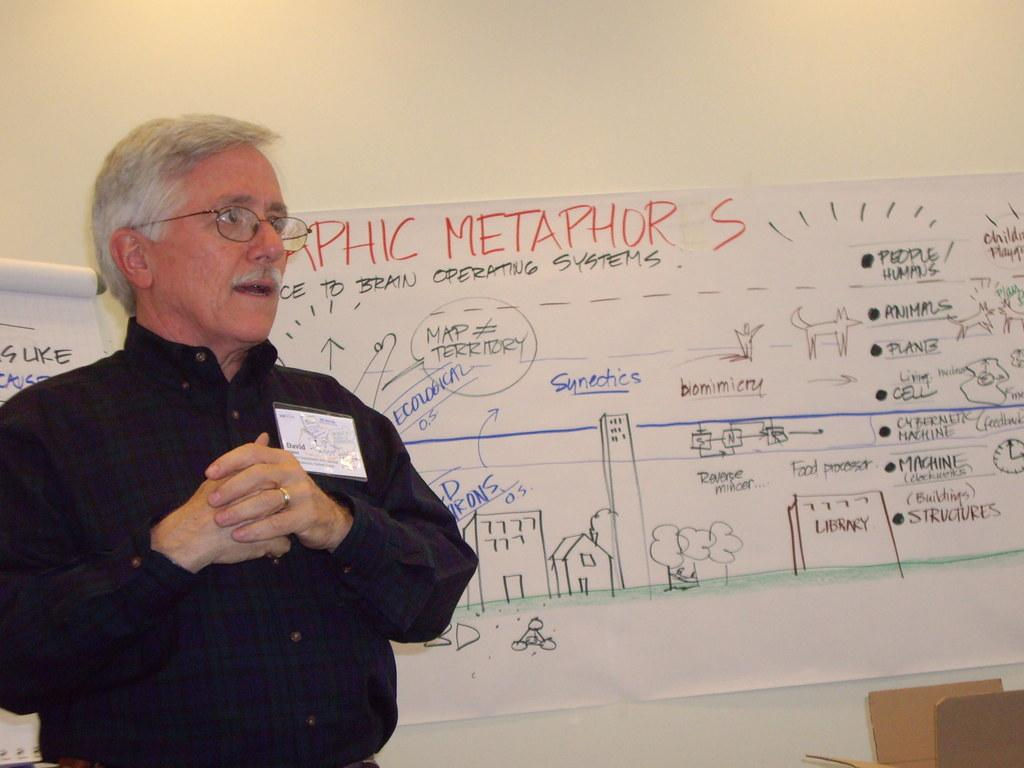<image>
Provide a brief description of the given image. a man stands in front of a white board reading Metaphor is wearing a black shirt 